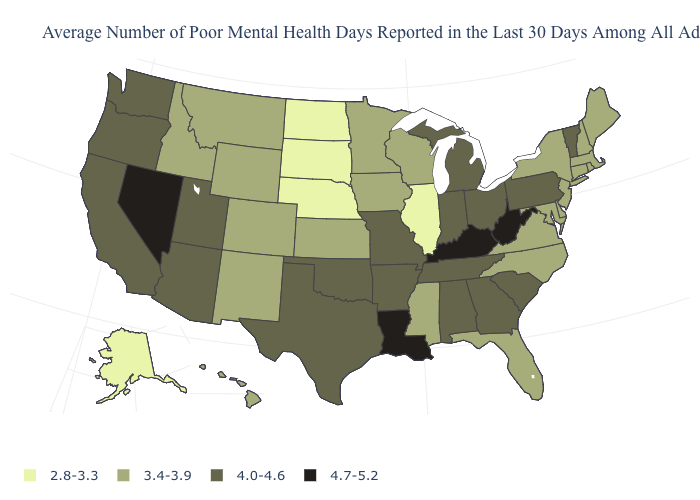What is the lowest value in states that border Ohio?
Write a very short answer. 4.0-4.6. What is the value of Arkansas?
Give a very brief answer. 4.0-4.6. Does South Carolina have a higher value than Alabama?
Quick response, please. No. Is the legend a continuous bar?
Be succinct. No. What is the value of West Virginia?
Answer briefly. 4.7-5.2. What is the value of Texas?
Concise answer only. 4.0-4.6. Name the states that have a value in the range 4.0-4.6?
Short answer required. Alabama, Arizona, Arkansas, California, Georgia, Indiana, Michigan, Missouri, Ohio, Oklahoma, Oregon, Pennsylvania, South Carolina, Tennessee, Texas, Utah, Vermont, Washington. Which states hav the highest value in the Northeast?
Short answer required. Pennsylvania, Vermont. Name the states that have a value in the range 4.0-4.6?
Quick response, please. Alabama, Arizona, Arkansas, California, Georgia, Indiana, Michigan, Missouri, Ohio, Oklahoma, Oregon, Pennsylvania, South Carolina, Tennessee, Texas, Utah, Vermont, Washington. Which states have the lowest value in the USA?
Write a very short answer. Alaska, Illinois, Nebraska, North Dakota, South Dakota. Does Alaska have the lowest value in the USA?
Be succinct. Yes. What is the highest value in the West ?
Give a very brief answer. 4.7-5.2. Name the states that have a value in the range 4.0-4.6?
Write a very short answer. Alabama, Arizona, Arkansas, California, Georgia, Indiana, Michigan, Missouri, Ohio, Oklahoma, Oregon, Pennsylvania, South Carolina, Tennessee, Texas, Utah, Vermont, Washington. What is the lowest value in the MidWest?
Short answer required. 2.8-3.3. What is the value of Delaware?
Concise answer only. 3.4-3.9. 